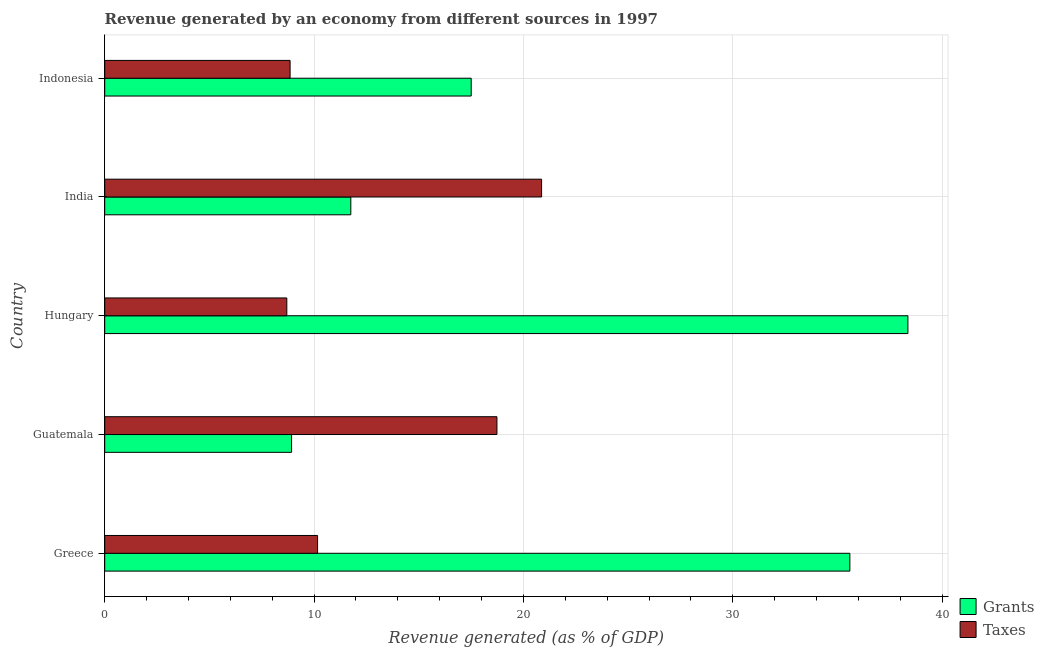Are the number of bars on each tick of the Y-axis equal?
Ensure brevity in your answer.  Yes. How many bars are there on the 2nd tick from the bottom?
Provide a short and direct response. 2. What is the label of the 5th group of bars from the top?
Your response must be concise. Greece. In how many cases, is the number of bars for a given country not equal to the number of legend labels?
Your answer should be compact. 0. What is the revenue generated by grants in India?
Offer a terse response. 11.75. Across all countries, what is the maximum revenue generated by grants?
Provide a short and direct response. 38.36. Across all countries, what is the minimum revenue generated by grants?
Keep it short and to the point. 8.92. In which country was the revenue generated by taxes maximum?
Offer a terse response. India. In which country was the revenue generated by grants minimum?
Ensure brevity in your answer.  Guatemala. What is the total revenue generated by taxes in the graph?
Your answer should be very brief. 67.32. What is the difference between the revenue generated by grants in Hungary and that in India?
Keep it short and to the point. 26.61. What is the difference between the revenue generated by taxes in Guatemala and the revenue generated by grants in Greece?
Offer a very short reply. -16.86. What is the average revenue generated by taxes per country?
Your response must be concise. 13.46. What is the difference between the revenue generated by grants and revenue generated by taxes in Hungary?
Your answer should be compact. 29.66. What is the ratio of the revenue generated by grants in Guatemala to that in Hungary?
Make the answer very short. 0.23. Is the difference between the revenue generated by taxes in Greece and Guatemala greater than the difference between the revenue generated by grants in Greece and Guatemala?
Keep it short and to the point. No. What is the difference between the highest and the second highest revenue generated by taxes?
Offer a terse response. 2.13. What is the difference between the highest and the lowest revenue generated by taxes?
Your answer should be compact. 12.17. What does the 1st bar from the top in Guatemala represents?
Provide a short and direct response. Taxes. What does the 1st bar from the bottom in Hungary represents?
Provide a succinct answer. Grants. How many bars are there?
Offer a terse response. 10. How many countries are there in the graph?
Provide a succinct answer. 5. What is the difference between two consecutive major ticks on the X-axis?
Your answer should be compact. 10. Does the graph contain grids?
Provide a short and direct response. Yes. Where does the legend appear in the graph?
Offer a terse response. Bottom right. What is the title of the graph?
Make the answer very short. Revenue generated by an economy from different sources in 1997. What is the label or title of the X-axis?
Provide a succinct answer. Revenue generated (as % of GDP). What is the Revenue generated (as % of GDP) of Grants in Greece?
Your response must be concise. 35.59. What is the Revenue generated (as % of GDP) in Taxes in Greece?
Keep it short and to the point. 10.17. What is the Revenue generated (as % of GDP) in Grants in Guatemala?
Offer a terse response. 8.92. What is the Revenue generated (as % of GDP) in Taxes in Guatemala?
Keep it short and to the point. 18.73. What is the Revenue generated (as % of GDP) in Grants in Hungary?
Give a very brief answer. 38.36. What is the Revenue generated (as % of GDP) in Taxes in Hungary?
Offer a terse response. 8.7. What is the Revenue generated (as % of GDP) in Grants in India?
Give a very brief answer. 11.75. What is the Revenue generated (as % of GDP) in Taxes in India?
Ensure brevity in your answer.  20.87. What is the Revenue generated (as % of GDP) in Grants in Indonesia?
Provide a short and direct response. 17.5. What is the Revenue generated (as % of GDP) in Taxes in Indonesia?
Provide a short and direct response. 8.85. Across all countries, what is the maximum Revenue generated (as % of GDP) of Grants?
Your answer should be compact. 38.36. Across all countries, what is the maximum Revenue generated (as % of GDP) of Taxes?
Your answer should be very brief. 20.87. Across all countries, what is the minimum Revenue generated (as % of GDP) in Grants?
Offer a terse response. 8.92. Across all countries, what is the minimum Revenue generated (as % of GDP) of Taxes?
Make the answer very short. 8.7. What is the total Revenue generated (as % of GDP) of Grants in the graph?
Make the answer very short. 112.14. What is the total Revenue generated (as % of GDP) in Taxes in the graph?
Provide a succinct answer. 67.32. What is the difference between the Revenue generated (as % of GDP) of Grants in Greece and that in Guatemala?
Keep it short and to the point. 26.66. What is the difference between the Revenue generated (as % of GDP) in Taxes in Greece and that in Guatemala?
Offer a terse response. -8.57. What is the difference between the Revenue generated (as % of GDP) in Grants in Greece and that in Hungary?
Provide a short and direct response. -2.77. What is the difference between the Revenue generated (as % of GDP) of Taxes in Greece and that in Hungary?
Your answer should be very brief. 1.47. What is the difference between the Revenue generated (as % of GDP) in Grants in Greece and that in India?
Your response must be concise. 23.84. What is the difference between the Revenue generated (as % of GDP) in Taxes in Greece and that in India?
Give a very brief answer. -10.7. What is the difference between the Revenue generated (as % of GDP) of Grants in Greece and that in Indonesia?
Provide a succinct answer. 18.09. What is the difference between the Revenue generated (as % of GDP) of Taxes in Greece and that in Indonesia?
Give a very brief answer. 1.31. What is the difference between the Revenue generated (as % of GDP) in Grants in Guatemala and that in Hungary?
Provide a succinct answer. -29.44. What is the difference between the Revenue generated (as % of GDP) of Taxes in Guatemala and that in Hungary?
Provide a short and direct response. 10.04. What is the difference between the Revenue generated (as % of GDP) in Grants in Guatemala and that in India?
Make the answer very short. -2.83. What is the difference between the Revenue generated (as % of GDP) of Taxes in Guatemala and that in India?
Your answer should be compact. -2.13. What is the difference between the Revenue generated (as % of GDP) in Grants in Guatemala and that in Indonesia?
Make the answer very short. -8.58. What is the difference between the Revenue generated (as % of GDP) of Taxes in Guatemala and that in Indonesia?
Your answer should be very brief. 9.88. What is the difference between the Revenue generated (as % of GDP) of Grants in Hungary and that in India?
Your answer should be very brief. 26.61. What is the difference between the Revenue generated (as % of GDP) in Taxes in Hungary and that in India?
Your response must be concise. -12.17. What is the difference between the Revenue generated (as % of GDP) in Grants in Hungary and that in Indonesia?
Provide a short and direct response. 20.86. What is the difference between the Revenue generated (as % of GDP) in Taxes in Hungary and that in Indonesia?
Your answer should be very brief. -0.16. What is the difference between the Revenue generated (as % of GDP) in Grants in India and that in Indonesia?
Your answer should be compact. -5.75. What is the difference between the Revenue generated (as % of GDP) in Taxes in India and that in Indonesia?
Your answer should be compact. 12.01. What is the difference between the Revenue generated (as % of GDP) of Grants in Greece and the Revenue generated (as % of GDP) of Taxes in Guatemala?
Offer a terse response. 16.86. What is the difference between the Revenue generated (as % of GDP) in Grants in Greece and the Revenue generated (as % of GDP) in Taxes in Hungary?
Offer a very short reply. 26.89. What is the difference between the Revenue generated (as % of GDP) of Grants in Greece and the Revenue generated (as % of GDP) of Taxes in India?
Offer a terse response. 14.72. What is the difference between the Revenue generated (as % of GDP) of Grants in Greece and the Revenue generated (as % of GDP) of Taxes in Indonesia?
Provide a short and direct response. 26.74. What is the difference between the Revenue generated (as % of GDP) of Grants in Guatemala and the Revenue generated (as % of GDP) of Taxes in Hungary?
Your answer should be compact. 0.23. What is the difference between the Revenue generated (as % of GDP) in Grants in Guatemala and the Revenue generated (as % of GDP) in Taxes in India?
Provide a succinct answer. -11.94. What is the difference between the Revenue generated (as % of GDP) of Grants in Guatemala and the Revenue generated (as % of GDP) of Taxes in Indonesia?
Provide a short and direct response. 0.07. What is the difference between the Revenue generated (as % of GDP) in Grants in Hungary and the Revenue generated (as % of GDP) in Taxes in India?
Offer a very short reply. 17.5. What is the difference between the Revenue generated (as % of GDP) of Grants in Hungary and the Revenue generated (as % of GDP) of Taxes in Indonesia?
Your answer should be compact. 29.51. What is the average Revenue generated (as % of GDP) in Grants per country?
Your answer should be compact. 22.43. What is the average Revenue generated (as % of GDP) of Taxes per country?
Give a very brief answer. 13.46. What is the difference between the Revenue generated (as % of GDP) in Grants and Revenue generated (as % of GDP) in Taxes in Greece?
Your response must be concise. 25.42. What is the difference between the Revenue generated (as % of GDP) in Grants and Revenue generated (as % of GDP) in Taxes in Guatemala?
Make the answer very short. -9.81. What is the difference between the Revenue generated (as % of GDP) in Grants and Revenue generated (as % of GDP) in Taxes in Hungary?
Offer a terse response. 29.67. What is the difference between the Revenue generated (as % of GDP) of Grants and Revenue generated (as % of GDP) of Taxes in India?
Offer a very short reply. -9.11. What is the difference between the Revenue generated (as % of GDP) in Grants and Revenue generated (as % of GDP) in Taxes in Indonesia?
Offer a terse response. 8.65. What is the ratio of the Revenue generated (as % of GDP) of Grants in Greece to that in Guatemala?
Give a very brief answer. 3.99. What is the ratio of the Revenue generated (as % of GDP) in Taxes in Greece to that in Guatemala?
Give a very brief answer. 0.54. What is the ratio of the Revenue generated (as % of GDP) of Grants in Greece to that in Hungary?
Ensure brevity in your answer.  0.93. What is the ratio of the Revenue generated (as % of GDP) in Taxes in Greece to that in Hungary?
Offer a very short reply. 1.17. What is the ratio of the Revenue generated (as % of GDP) in Grants in Greece to that in India?
Offer a very short reply. 3.03. What is the ratio of the Revenue generated (as % of GDP) in Taxes in Greece to that in India?
Your response must be concise. 0.49. What is the ratio of the Revenue generated (as % of GDP) in Grants in Greece to that in Indonesia?
Your response must be concise. 2.03. What is the ratio of the Revenue generated (as % of GDP) in Taxes in Greece to that in Indonesia?
Your answer should be compact. 1.15. What is the ratio of the Revenue generated (as % of GDP) of Grants in Guatemala to that in Hungary?
Offer a very short reply. 0.23. What is the ratio of the Revenue generated (as % of GDP) of Taxes in Guatemala to that in Hungary?
Your answer should be very brief. 2.15. What is the ratio of the Revenue generated (as % of GDP) in Grants in Guatemala to that in India?
Your answer should be very brief. 0.76. What is the ratio of the Revenue generated (as % of GDP) of Taxes in Guatemala to that in India?
Keep it short and to the point. 0.9. What is the ratio of the Revenue generated (as % of GDP) of Grants in Guatemala to that in Indonesia?
Provide a succinct answer. 0.51. What is the ratio of the Revenue generated (as % of GDP) in Taxes in Guatemala to that in Indonesia?
Make the answer very short. 2.12. What is the ratio of the Revenue generated (as % of GDP) of Grants in Hungary to that in India?
Provide a succinct answer. 3.26. What is the ratio of the Revenue generated (as % of GDP) of Taxes in Hungary to that in India?
Provide a short and direct response. 0.42. What is the ratio of the Revenue generated (as % of GDP) of Grants in Hungary to that in Indonesia?
Offer a very short reply. 2.19. What is the ratio of the Revenue generated (as % of GDP) in Taxes in Hungary to that in Indonesia?
Ensure brevity in your answer.  0.98. What is the ratio of the Revenue generated (as % of GDP) in Grants in India to that in Indonesia?
Your answer should be very brief. 0.67. What is the ratio of the Revenue generated (as % of GDP) in Taxes in India to that in Indonesia?
Provide a succinct answer. 2.36. What is the difference between the highest and the second highest Revenue generated (as % of GDP) of Grants?
Give a very brief answer. 2.77. What is the difference between the highest and the second highest Revenue generated (as % of GDP) in Taxes?
Your answer should be compact. 2.13. What is the difference between the highest and the lowest Revenue generated (as % of GDP) of Grants?
Provide a succinct answer. 29.44. What is the difference between the highest and the lowest Revenue generated (as % of GDP) of Taxes?
Provide a short and direct response. 12.17. 